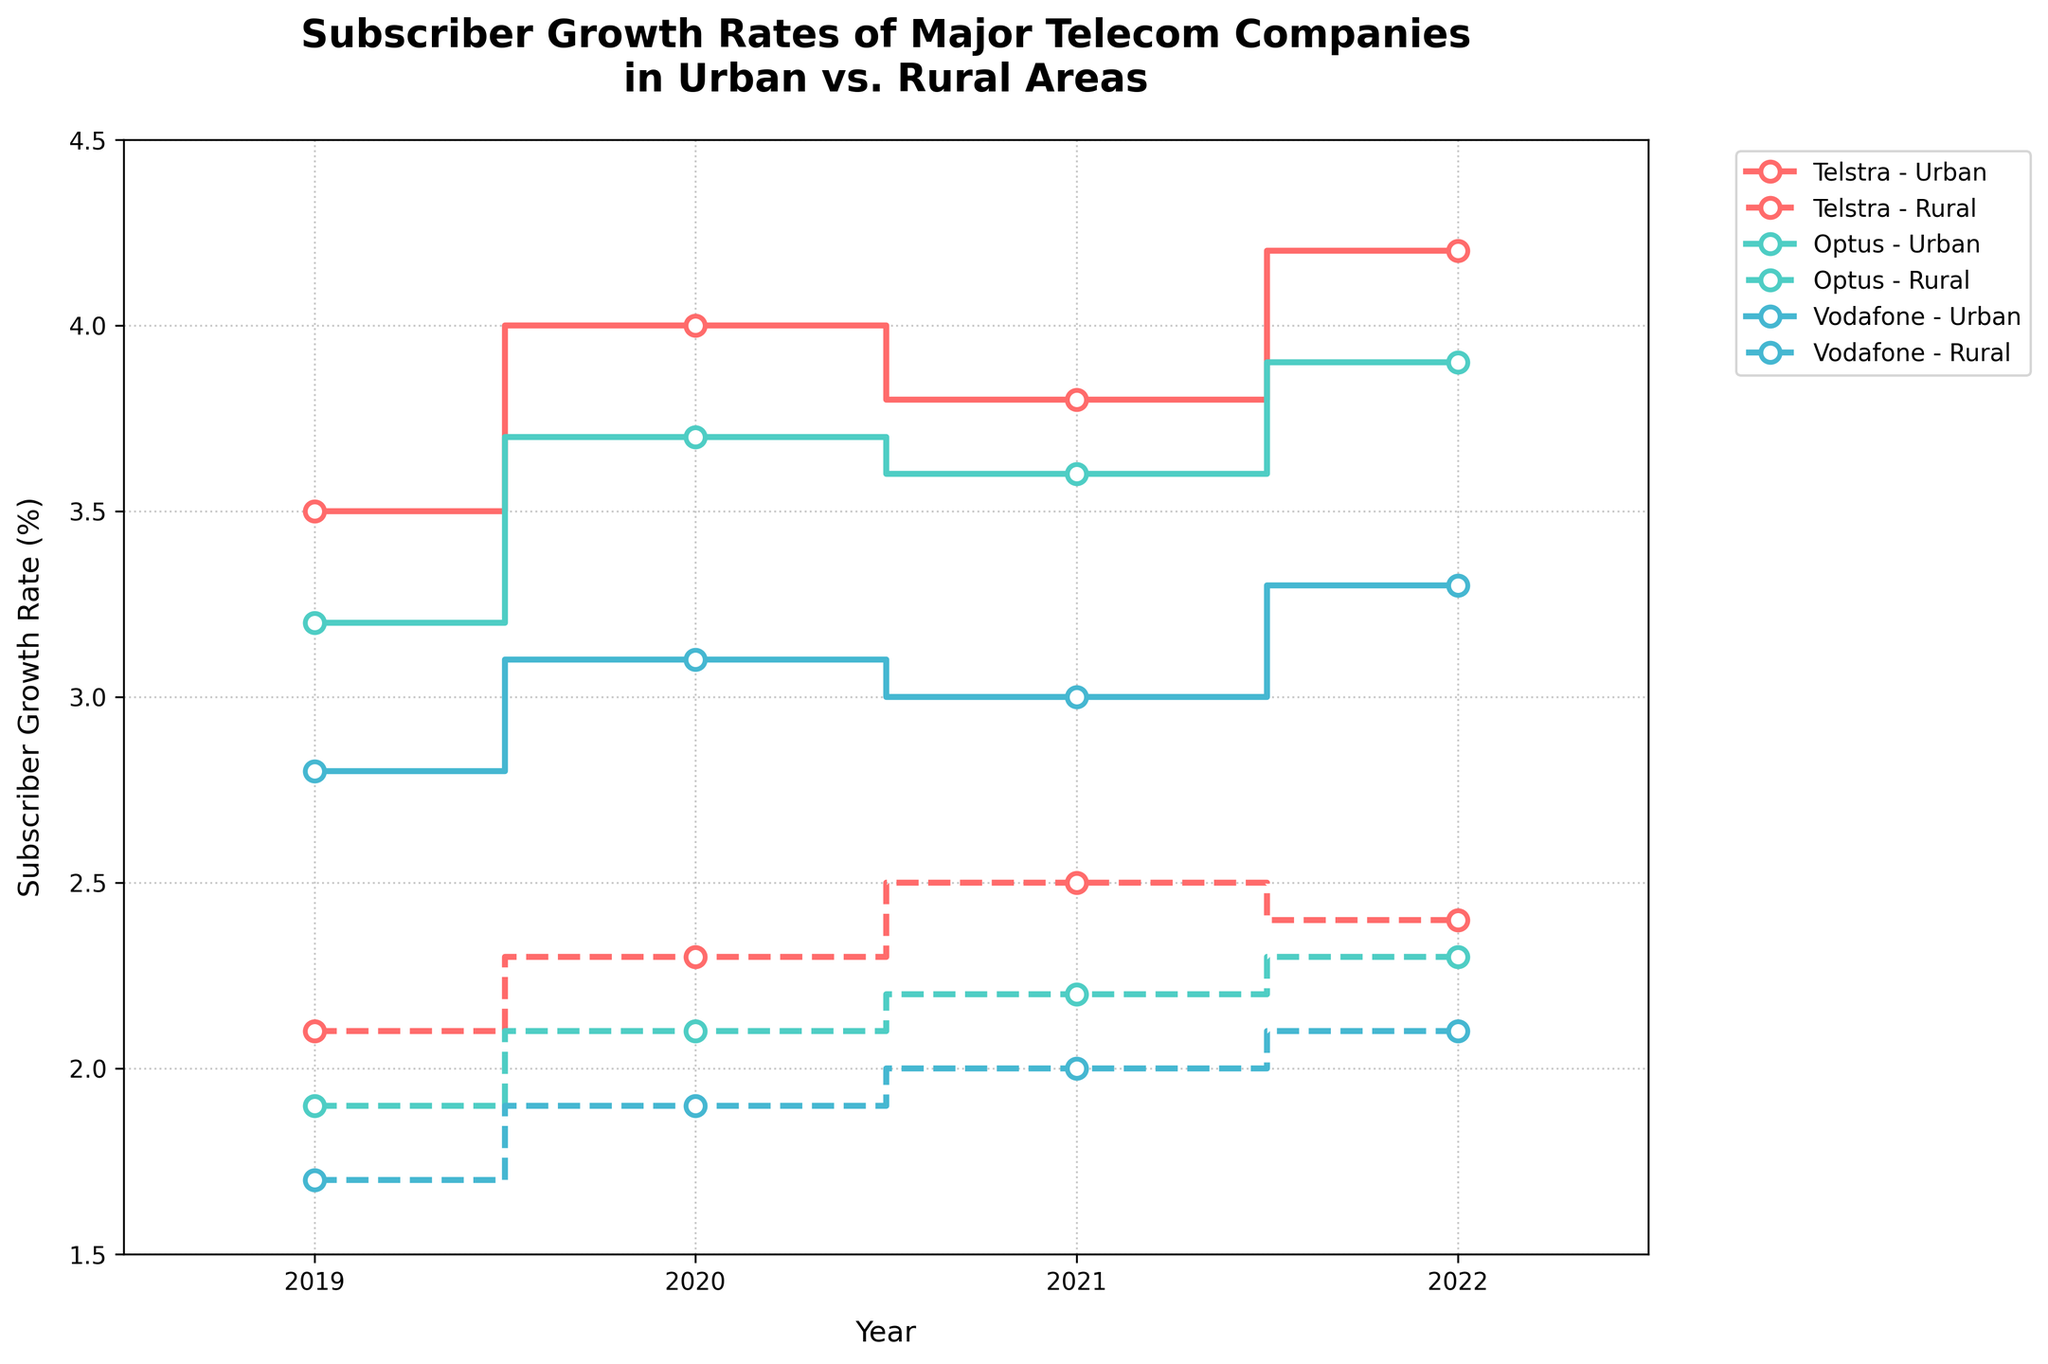What is the title of the plot? The title is typically found at the top of the plot, prominently displaying the main subject of the visualization. The title here is "Subscriber Growth Rates of Major Telecom Companies in Urban vs. Rural Areas."
Answer: Subscriber Growth Rates of Major Telecom Companies in Urban vs. Rural Areas How many companies are represented in the plot? The legend or the different series in the plot indicate the distinct companies. We can see there are three companies represented by three sets of colored lines.
Answer: Three What color represents Telstra in the plot? By examining the legend, we can see that Telstra is represented by a specific color (likely coded as the first color in the list). Telstra's lines are colored in red tones.
Answer: Red Which company had the highest subscriber growth rate in urban areas in 2020? We observe the lines for urban areas and check the values for 2020. Telstra's urban line is at 4.0%, Optus's urban line is at 3.7%, and Vodafone's urban line is at 3.1%. The highest value among them is from Telstra's urban line.
Answer: Telstra What is the difference in subscriber growth rate between urban and rural areas for Optus in 2022? We find Optus's urban and rural lines at the year 2022. The values are 3.9% for urban and 2.3% for rural. The difference is 3.9% - 2.3% = 1.6%.
Answer: 1.6% In which year did Telstra's rural subscribers experience the highest growth rate? We trace the rural line for Telstra and identify the peak value. It reaches its highest at 2.5% in the year 2021.
Answer: 2021 How does Vodafone's urban growth rate in 2022 compare to its rural growth rate in 2020? We locate Vodafone's urban line in 2022, which has a growth rate of 3.3%, and compare it with the rural line in 2020, which has a rate of 1.9%. 3.3% is greater than 1.9%, so the urban growth rate in 2022 is higher than the rural growth rate in 2020.
Answer: Higher Calculate the average subscriber growth rate for Optus in rural areas from 2019 to 2022. We take the rural growth rates for Optus for the years 2019, 2020, 2021, and 2022: 1.9%, 2.1%, 2.2%, and 2.3%. Average = (1.9 + 2.1 + 2.2 + 2.3) / 4 = 2.125%.
Answer: 2.125% Did any company have a decrease in its rural subscriber growth rate from 2021 to 2022? We look at the rural lines for any downward steps from 2021 to 2022. Telstra had a decrease from 2.5% to 2.4%.
Answer: Yes Which company showed the most consistent subscriber growth in urban areas from 2019 to 2022 based on the visual trends? We look for the company whose urban line shows the least fluctuation over the years visually. Optus’s urban line appears the most consistent in its upward trend without large variations.
Answer: Optus 